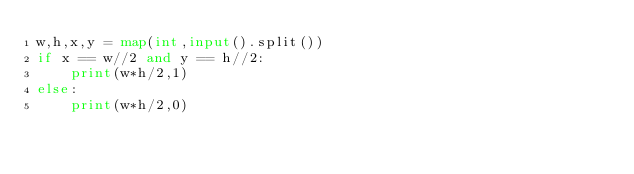<code> <loc_0><loc_0><loc_500><loc_500><_Python_>w,h,x,y = map(int,input().split())
if x == w//2 and y == h//2:
    print(w*h/2,1)
else:
    print(w*h/2,0)</code> 